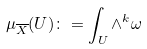Convert formula to latex. <formula><loc_0><loc_0><loc_500><loc_500>\mu _ { \overline { X } } ( U ) \colon = \int _ { U } \wedge ^ { k } \omega</formula> 